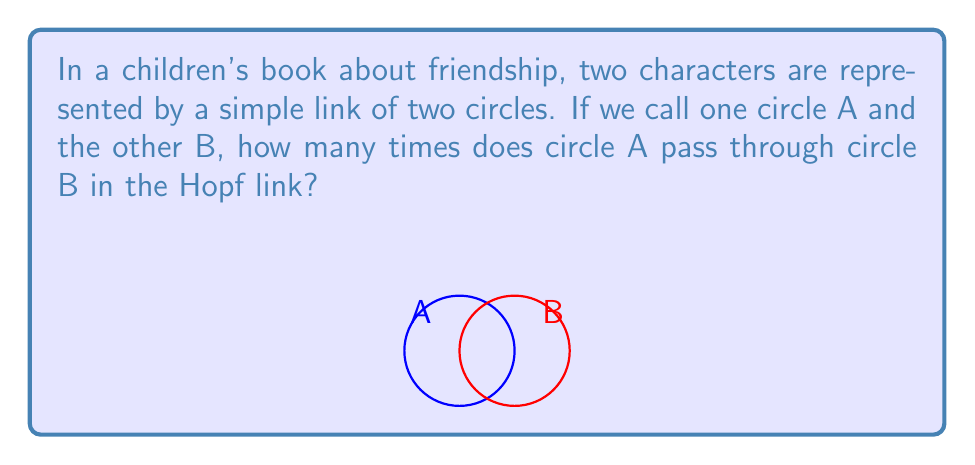Can you answer this question? Let's break this down step-by-step:

1) First, we need to understand what a Hopf link is. It's the simplest non-trivial link of two circles, where each circle is linked with the other exactly once.

2) In topology, we're interested in how the components of a link are intertwined. For the Hopf link, we look at how many times one circle passes through the other.

3) To count this, we can imagine "pushing" one circle (let's say circle A) through the other (circle B) until it comes back to its starting position.

4) As we do this, we'll notice that circle A passes through circle B exactly twice:
   - Once when it goes "into" the space enclosed by circle B
   - Once when it comes "out" of that space

5) This is true regardless of which circle we consider as A and which as B, due to the symmetry of the Hopf link.

6) It's important to note that this count of 2 is a topological invariant of the Hopf link. No matter how we deform the link (without cutting or gluing), this number will always be 2.

7) In the context of the children's book, this could represent how the two friends are connected in two special ways, symbolizing a strong, reciprocal friendship.
Answer: Circle A passes through circle B exactly $2$ times in the Hopf link. 